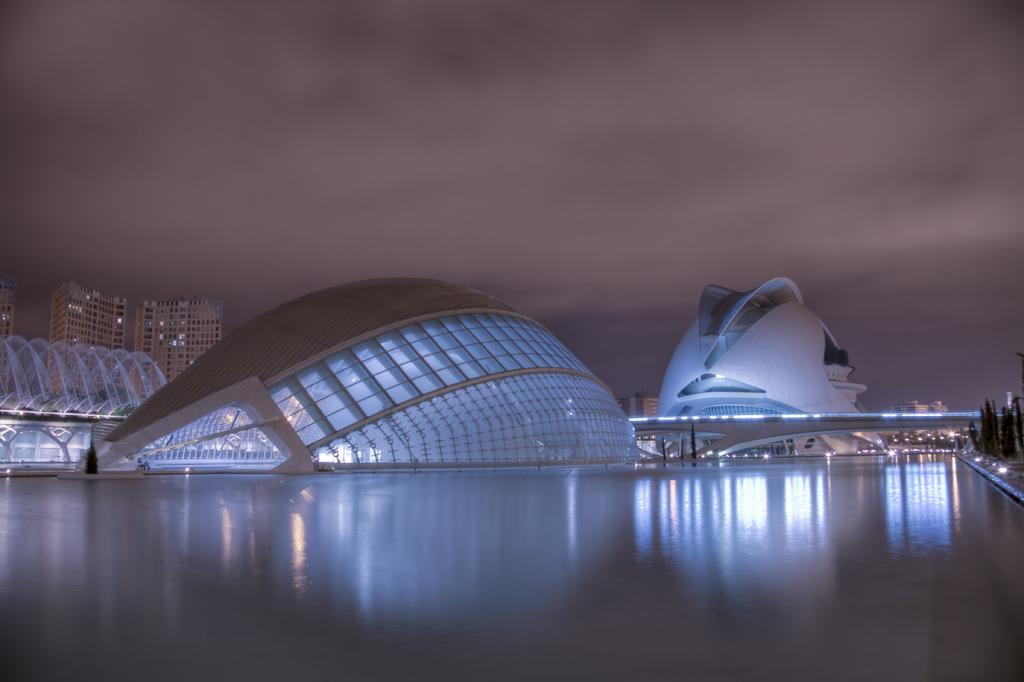Please provide a concise description of this image. In this picture we can see buildings, trees, bridge, water, lights and in the background we can see the sky with clouds. 